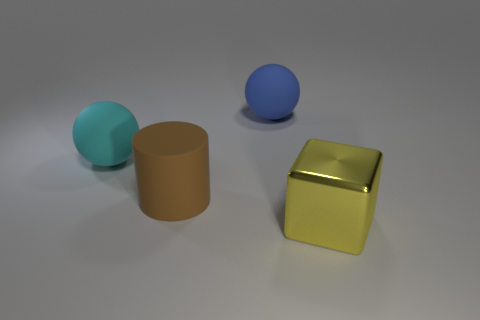Add 2 blocks. How many objects exist? 6 Subtract all cubes. How many objects are left? 3 Add 1 large cyan matte balls. How many large cyan matte balls exist? 2 Subtract 0 brown spheres. How many objects are left? 4 Subtract all small gray metal things. Subtract all big blue objects. How many objects are left? 3 Add 1 brown matte cylinders. How many brown matte cylinders are left? 2 